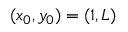Convert formula to latex. <formula><loc_0><loc_0><loc_500><loc_500>( x _ { 0 } , y _ { 0 } ) = ( 1 , L )</formula> 